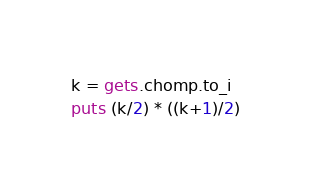Convert code to text. <code><loc_0><loc_0><loc_500><loc_500><_Ruby_>k = gets.chomp.to_i
puts (k/2) * ((k+1)/2)</code> 